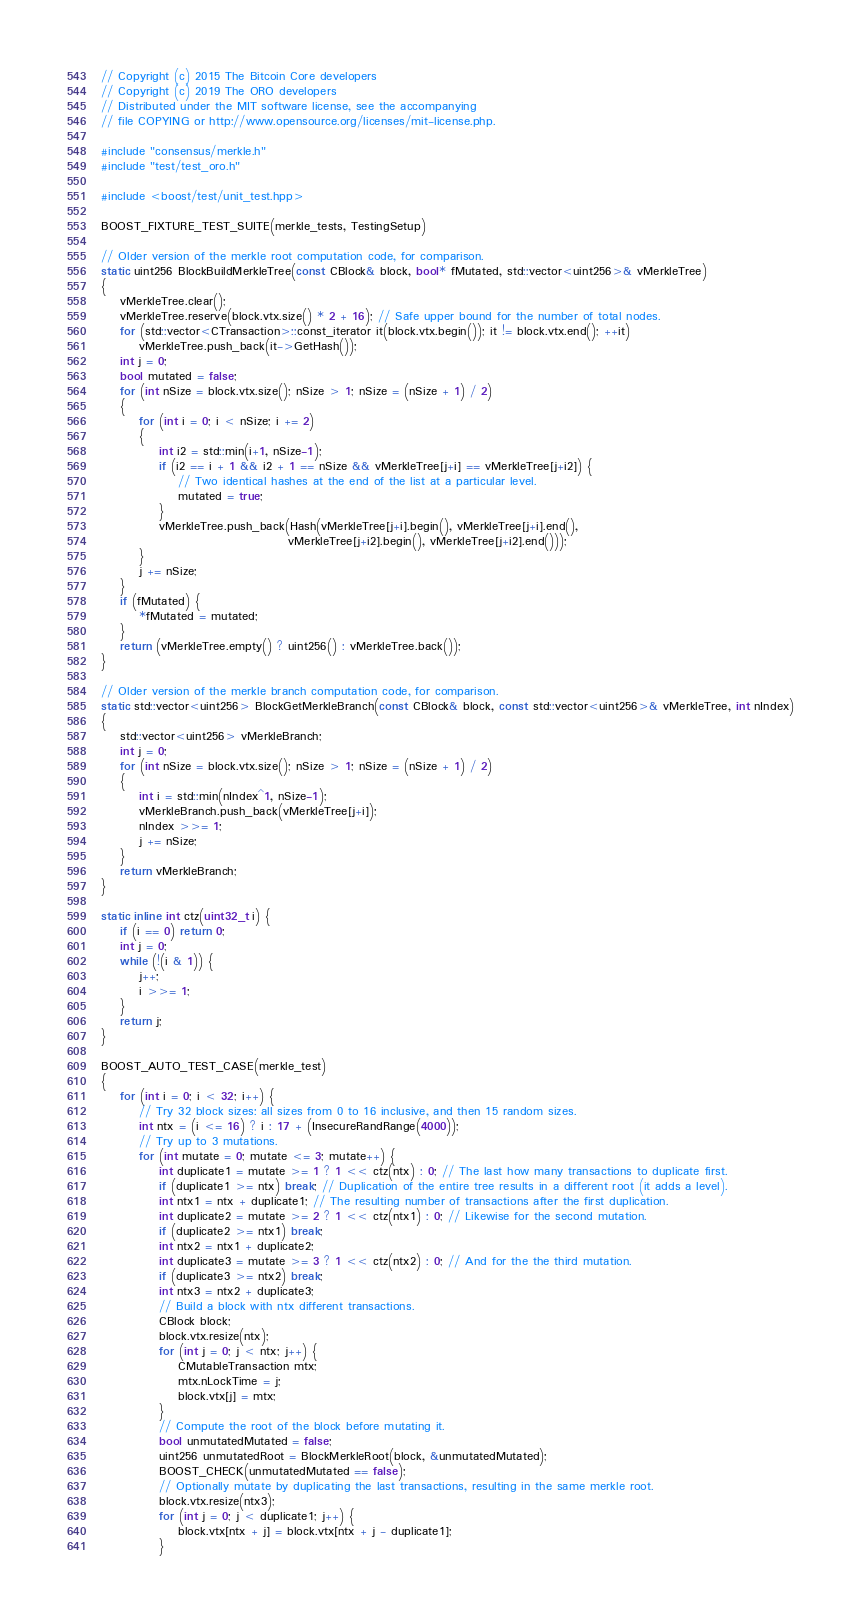Convert code to text. <code><loc_0><loc_0><loc_500><loc_500><_C++_>// Copyright (c) 2015 The Bitcoin Core developers
// Copyright (c) 2019 The ORO developers
// Distributed under the MIT software license, see the accompanying
// file COPYING or http://www.opensource.org/licenses/mit-license.php.

#include "consensus/merkle.h"
#include "test/test_oro.h"

#include <boost/test/unit_test.hpp>

BOOST_FIXTURE_TEST_SUITE(merkle_tests, TestingSetup)

// Older version of the merkle root computation code, for comparison.
static uint256 BlockBuildMerkleTree(const CBlock& block, bool* fMutated, std::vector<uint256>& vMerkleTree)
{
    vMerkleTree.clear();
    vMerkleTree.reserve(block.vtx.size() * 2 + 16); // Safe upper bound for the number of total nodes.
    for (std::vector<CTransaction>::const_iterator it(block.vtx.begin()); it != block.vtx.end(); ++it)
        vMerkleTree.push_back(it->GetHash());
    int j = 0;
    bool mutated = false;
    for (int nSize = block.vtx.size(); nSize > 1; nSize = (nSize + 1) / 2)
    {
        for (int i = 0; i < nSize; i += 2)
        {
            int i2 = std::min(i+1, nSize-1);
            if (i2 == i + 1 && i2 + 1 == nSize && vMerkleTree[j+i] == vMerkleTree[j+i2]) {
                // Two identical hashes at the end of the list at a particular level.
                mutated = true;
            }
            vMerkleTree.push_back(Hash(vMerkleTree[j+i].begin(), vMerkleTree[j+i].end(),
                                       vMerkleTree[j+i2].begin(), vMerkleTree[j+i2].end()));
        }
        j += nSize;
    }
    if (fMutated) {
        *fMutated = mutated;
    }
    return (vMerkleTree.empty() ? uint256() : vMerkleTree.back());
}

// Older version of the merkle branch computation code, for comparison.
static std::vector<uint256> BlockGetMerkleBranch(const CBlock& block, const std::vector<uint256>& vMerkleTree, int nIndex)
{
    std::vector<uint256> vMerkleBranch;
    int j = 0;
    for (int nSize = block.vtx.size(); nSize > 1; nSize = (nSize + 1) / 2)
    {
        int i = std::min(nIndex^1, nSize-1);
        vMerkleBranch.push_back(vMerkleTree[j+i]);
        nIndex >>= 1;
        j += nSize;
    }
    return vMerkleBranch;
}

static inline int ctz(uint32_t i) {
    if (i == 0) return 0;
    int j = 0;
    while (!(i & 1)) {
        j++;
        i >>= 1;
    }
    return j;
}

BOOST_AUTO_TEST_CASE(merkle_test)
{
    for (int i = 0; i < 32; i++) {
        // Try 32 block sizes: all sizes from 0 to 16 inclusive, and then 15 random sizes.
        int ntx = (i <= 16) ? i : 17 + (InsecureRandRange(4000));
        // Try up to 3 mutations.
        for (int mutate = 0; mutate <= 3; mutate++) {
            int duplicate1 = mutate >= 1 ? 1 << ctz(ntx) : 0; // The last how many transactions to duplicate first.
            if (duplicate1 >= ntx) break; // Duplication of the entire tree results in a different root (it adds a level).
            int ntx1 = ntx + duplicate1; // The resulting number of transactions after the first duplication.
            int duplicate2 = mutate >= 2 ? 1 << ctz(ntx1) : 0; // Likewise for the second mutation.
            if (duplicate2 >= ntx1) break;
            int ntx2 = ntx1 + duplicate2;
            int duplicate3 = mutate >= 3 ? 1 << ctz(ntx2) : 0; // And for the the third mutation.
            if (duplicate3 >= ntx2) break;
            int ntx3 = ntx2 + duplicate3;
            // Build a block with ntx different transactions.
            CBlock block;
            block.vtx.resize(ntx);
            for (int j = 0; j < ntx; j++) {
                CMutableTransaction mtx;
                mtx.nLockTime = j;
                block.vtx[j] = mtx;
            }
            // Compute the root of the block before mutating it.
            bool unmutatedMutated = false;
            uint256 unmutatedRoot = BlockMerkleRoot(block, &unmutatedMutated);
            BOOST_CHECK(unmutatedMutated == false);
            // Optionally mutate by duplicating the last transactions, resulting in the same merkle root.
            block.vtx.resize(ntx3);
            for (int j = 0; j < duplicate1; j++) {
                block.vtx[ntx + j] = block.vtx[ntx + j - duplicate1];
            }</code> 